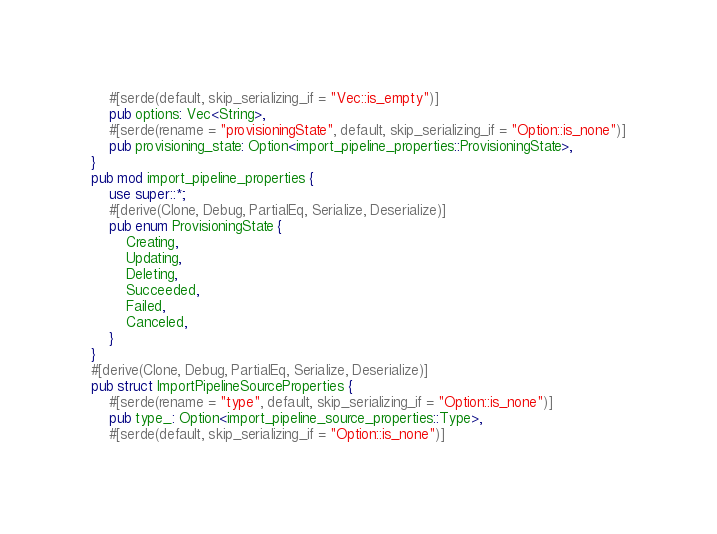Convert code to text. <code><loc_0><loc_0><loc_500><loc_500><_Rust_>    #[serde(default, skip_serializing_if = "Vec::is_empty")]
    pub options: Vec<String>,
    #[serde(rename = "provisioningState", default, skip_serializing_if = "Option::is_none")]
    pub provisioning_state: Option<import_pipeline_properties::ProvisioningState>,
}
pub mod import_pipeline_properties {
    use super::*;
    #[derive(Clone, Debug, PartialEq, Serialize, Deserialize)]
    pub enum ProvisioningState {
        Creating,
        Updating,
        Deleting,
        Succeeded,
        Failed,
        Canceled,
    }
}
#[derive(Clone, Debug, PartialEq, Serialize, Deserialize)]
pub struct ImportPipelineSourceProperties {
    #[serde(rename = "type", default, skip_serializing_if = "Option::is_none")]
    pub type_: Option<import_pipeline_source_properties::Type>,
    #[serde(default, skip_serializing_if = "Option::is_none")]</code> 